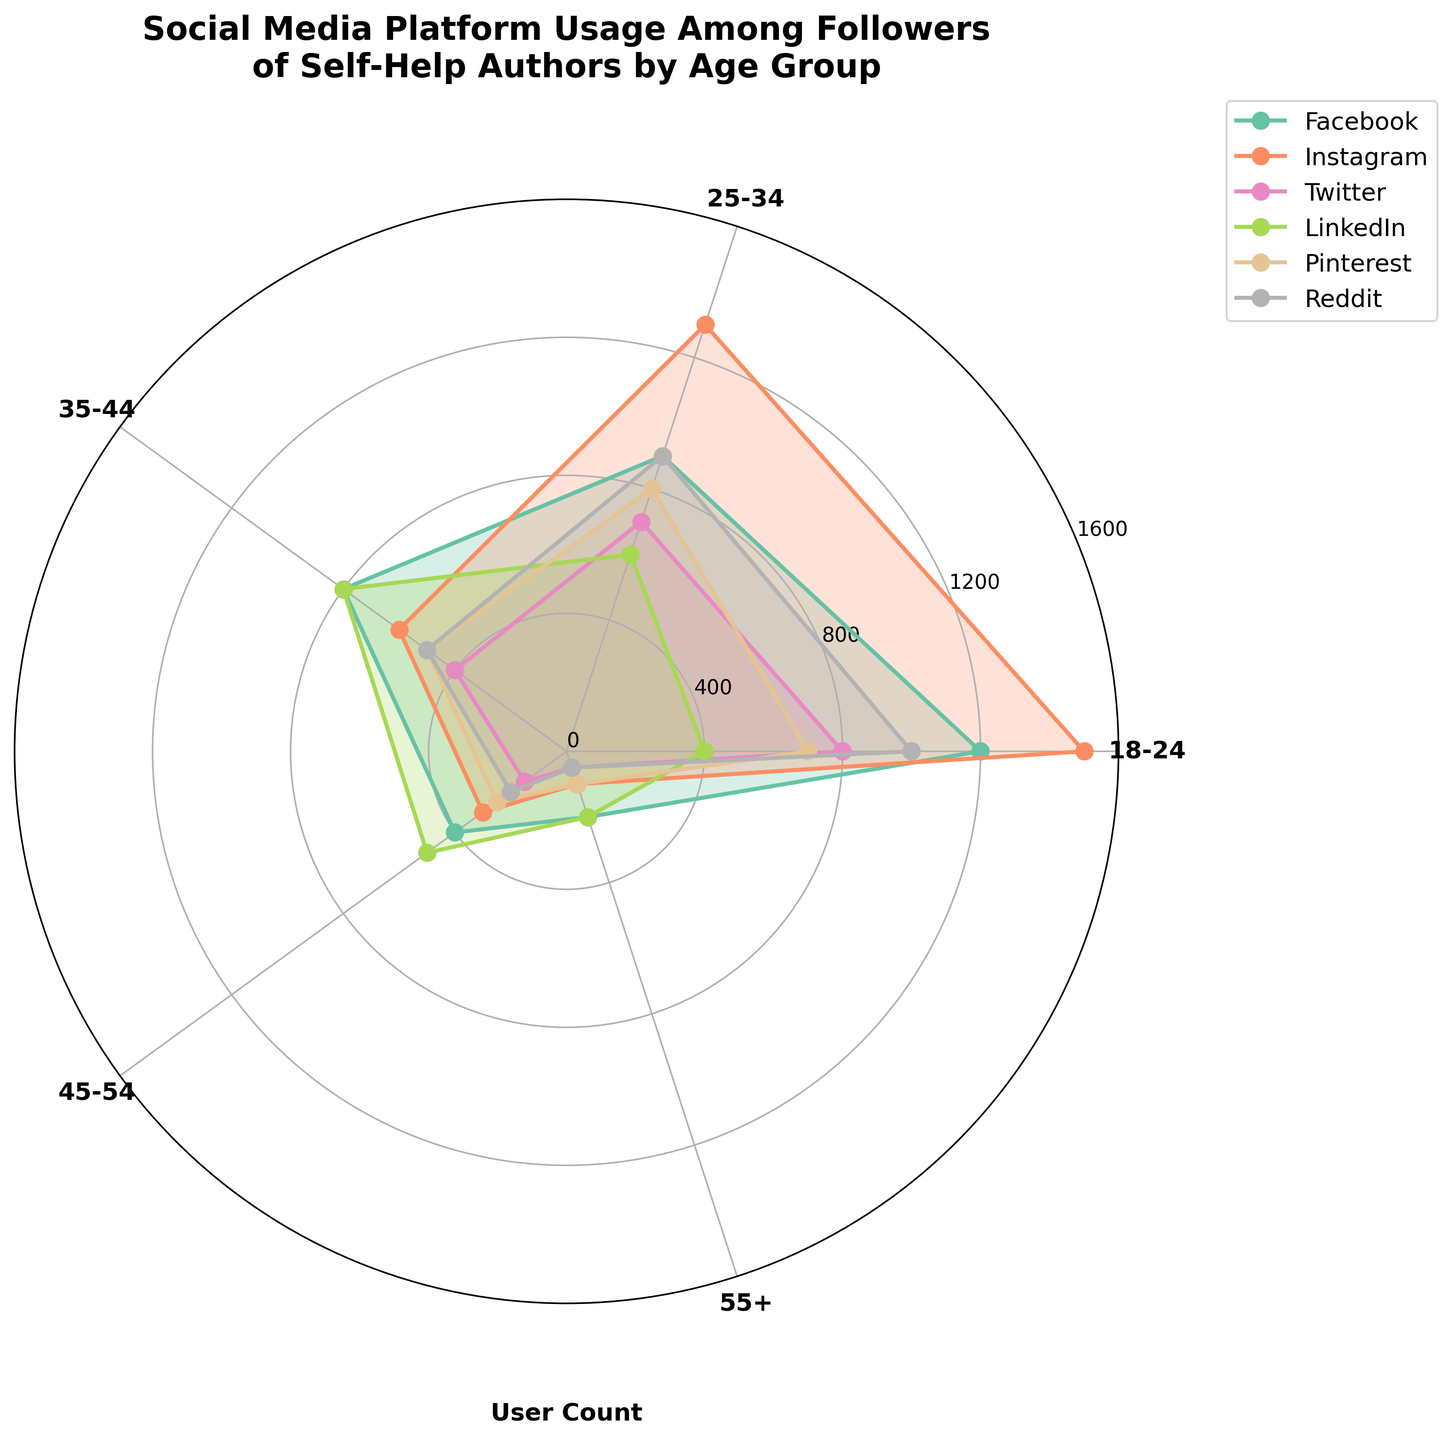What is the title of the figure? The title is displayed prominently at the top of the chart and reads "Social Media Platform Usage Among Followers of Self-Help Authors by Age Group."
Answer: Social Media Platform Usage Among Followers of Self-Help Authors by Age Group Which age group has the highest user count on Instagram? Looking at the radial extent of the lines representing Instagram, the 18-24 age group has the longest line, indicating the highest user count.
Answer: 18-24 Which platform has the fewest users in the 55+ age group? Observing the radial length of the lines for each platform, Twitter and Reddit have the shortest lines for the 55+ age group, equal to 50 user counts.
Answer: Twitter and Reddit What platform is most popular among the 35-44 age group? By comparing the radial extension of each line within the 35-44 age slice, LinkedIn has the longest line, indicating it has the highest user count for this age group.
Answer: LinkedIn How does the user count for Facebook compare between the 18-24 and 45-54 age groups? The line for Facebook in the 18-24 age group extends to 1200, while the line in the 45-54 age group extends to 400. Comparing these visually, 1200 is significantly greater than 400.
Answer: 18-24 has a higher count In which age group does Pinterest have roughly half the users compared to Instagram? For each age group, compare the lengths of the lines representing Pinterest and Instagram. In the 35-44 age group, Pinterest has roughly 500 users and Instagram has 1000 users, which is close to half.
Answer: 35-44 Which two platforms have a similar user count for the 25-34 age group, and what is that count? By examining the 25-34 age group lines, both Pinterest and Reddit have lines extending to approximately 900 users.
Answer: Pinterest and Reddit, 900 What is the average user count for the 25-34 age group across all platforms? Sum the user counts for all platforms in the 25-34 age group: Facebook (900), Instagram (1300), Twitter (700), LinkedIn (600), Pinterest (800), Reddit (900). Total = 5200. Average = 5200 / 6 = 866.67
Answer: 866.67 For the 55+ age group, rank the platforms from most to least users. Evaluate the lengths of the lines for the 55+ age group: Facebook (200), Instagram (100), Twitter (50), LinkedIn (200), Pinterest (100), Reddit (50). Rank: Facebook and LinkedIn (tie), followed by Instagram and Pinterest (tie), then Twitter and Reddit (tie).
Answer: Facebook, LinkedIn, Instagram, Pinterest, Twitter, Reddit 